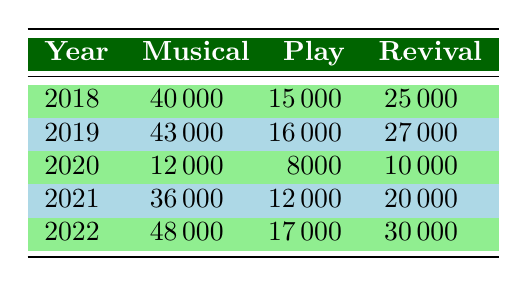What was the total ticket sales revenue for Musicals in 2021? In 2021, the ticket sales revenue for Musicals is listed as 36000000.
Answer: 36000000 Which genre had the highest ticket sales in 2022? In 2022, the revenues are 48000000 for Musicals, 17000000 for Plays, and 30000000 for Revivals. The highest is 48000000 from Musicals.
Answer: Musicals What was the difference in ticket sales revenue for Plays between 2018 and 2022? In 2018, Plays had revenues of 15000000, and in 2022, they had 17000000. The difference is 17000000 - 15000000 = 2000000.
Answer: 2000000 Did ticket sales for Revivals increase from 2020 to 2022? In 2020, Revivals had revenues of 10000000, and in 2022 they had 30000000. Since 30000000 > 10000000, the sales did increase.
Answer: Yes What was the average ticket sales revenue for Musicals from 2018 to 2022? The revenues for Musicals from 2018 to 2022 are 40000000, 43000000, 12000000, 36000000, and 48000000. The sum is 40000000 + 43000000 + 12000000 + 36000000 + 48000000 = 189000000. There are 5 data points, so the average is 189000000 / 5 = 37800000.
Answer: 37800000 What was the highest revenue for Plays during the given years? Looking at the table, the revenues for Plays are 15000000 in 2018, 16000000 in 2019, 8000000 in 2020, 12000000 in 2021, and 17000000 in 2022. The highest is 17000000 in 2022.
Answer: 17000000 Which genre showed a decline in ticket sales revenue from 2019 to 2020? In 2019, the revenues were 43000000 for Musicals, 16000000 for Plays, and 27000000 for Revivals. In 2020, they dropped to 12000000 for Musicals, 8000000 for Plays, and 10000000 for Revivals. All three genres saw declines, so the answer is all of them.
Answer: All genres How much more revenue did Musicals earn in 2022 than in 2021? In 2021, Musicals earned 36000000, and in 2022 they earned 48000000. The difference is 48000000 - 36000000 = 12000000.
Answer: 12000000 Did ticket sales for Revivals peak in 2022? In 2022, Revivals earned 30000000 whereas in the previous years they had 25000000 in 2018, 27000000 in 2019, 10000000 in 2020, and 20000000 in 2021. Since 30000000 is the highest, the peak occurred in 2022.
Answer: Yes 